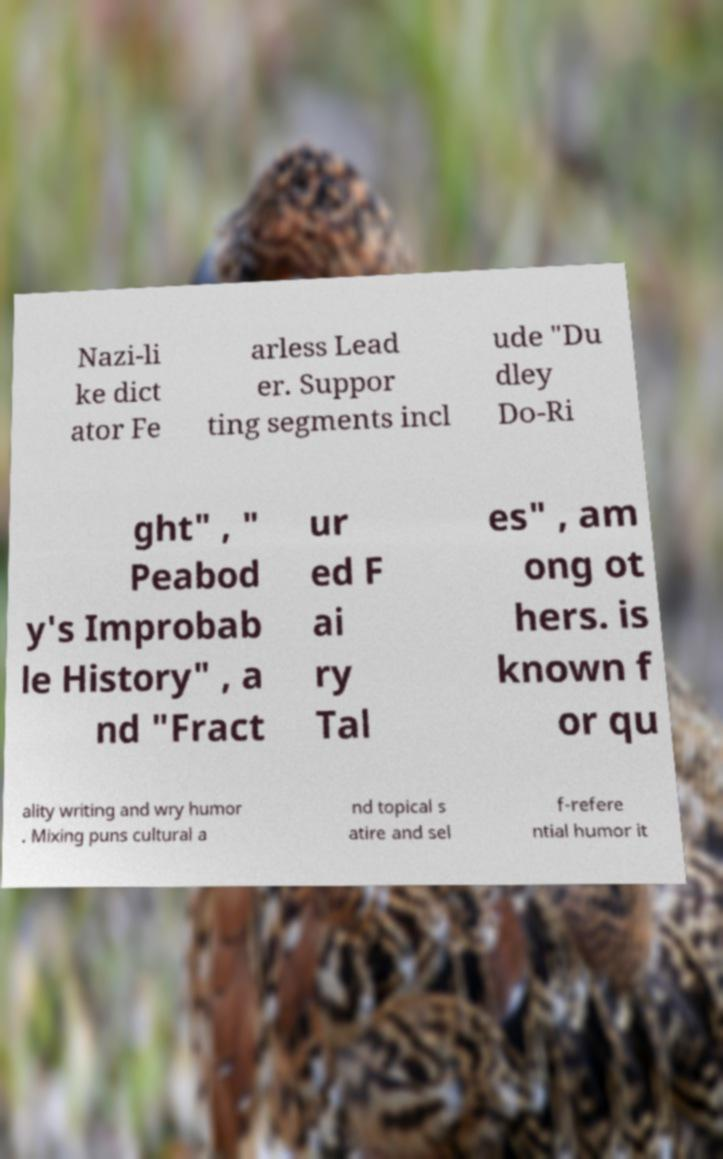What messages or text are displayed in this image? I need them in a readable, typed format. Nazi-li ke dict ator Fe arless Lead er. Suppor ting segments incl ude "Du dley Do-Ri ght" , " Peabod y's Improbab le History" , a nd "Fract ur ed F ai ry Tal es" , am ong ot hers. is known f or qu ality writing and wry humor . Mixing puns cultural a nd topical s atire and sel f-refere ntial humor it 